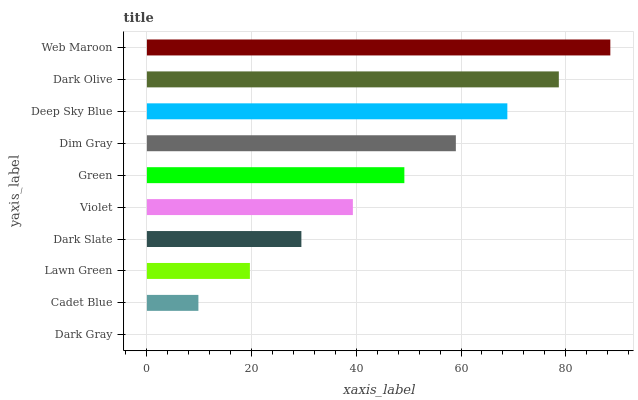Is Dark Gray the minimum?
Answer yes or no. Yes. Is Web Maroon the maximum?
Answer yes or no. Yes. Is Cadet Blue the minimum?
Answer yes or no. No. Is Cadet Blue the maximum?
Answer yes or no. No. Is Cadet Blue greater than Dark Gray?
Answer yes or no. Yes. Is Dark Gray less than Cadet Blue?
Answer yes or no. Yes. Is Dark Gray greater than Cadet Blue?
Answer yes or no. No. Is Cadet Blue less than Dark Gray?
Answer yes or no. No. Is Green the high median?
Answer yes or no. Yes. Is Violet the low median?
Answer yes or no. Yes. Is Dark Slate the high median?
Answer yes or no. No. Is Cadet Blue the low median?
Answer yes or no. No. 